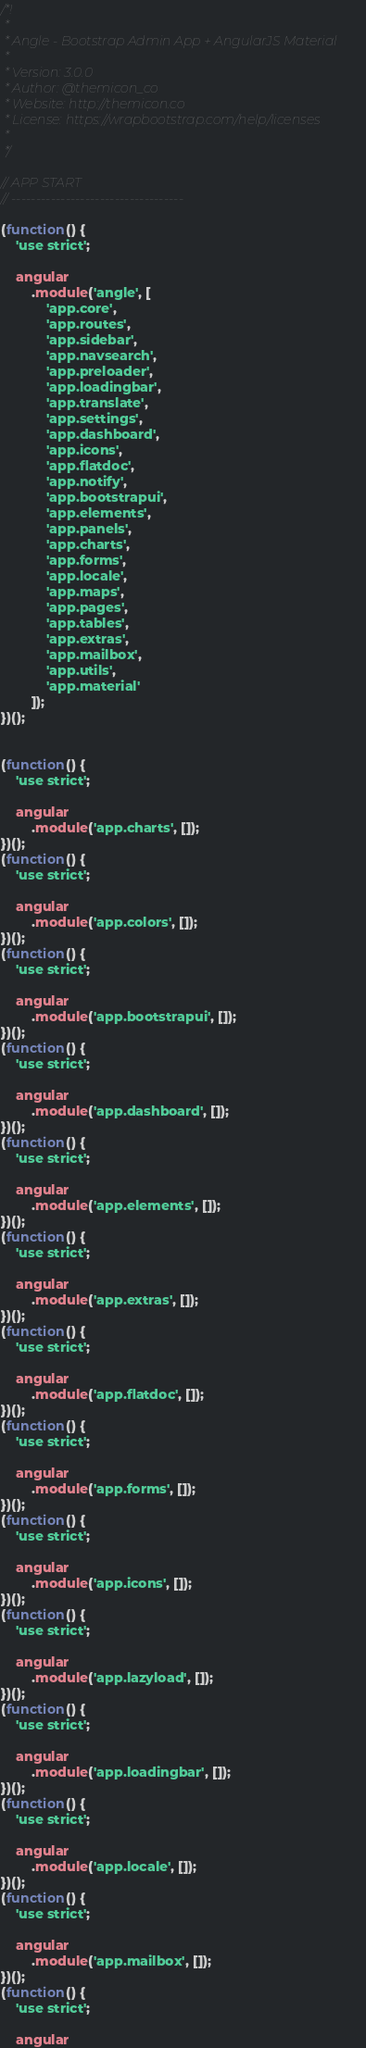Convert code to text. <code><loc_0><loc_0><loc_500><loc_500><_JavaScript_>/*!
 * 
 * Angle - Bootstrap Admin App + AngularJS Material
 * 
 * Version: 3.0.0
 * Author: @themicon_co
 * Website: http://themicon.co
 * License: https://wrapbootstrap.com/help/licenses
 * 
 */

// APP START
// ----------------------------------- 

(function() {
    'use strict';

    angular
        .module('angle', [
            'app.core',
            'app.routes',
            'app.sidebar',
            'app.navsearch',
            'app.preloader',
            'app.loadingbar',
            'app.translate',
            'app.settings',
            'app.dashboard',
            'app.icons',
            'app.flatdoc',
            'app.notify',
            'app.bootstrapui',
            'app.elements',
            'app.panels',
            'app.charts',
            'app.forms',
            'app.locale',
            'app.maps',
            'app.pages',
            'app.tables',
            'app.extras',
            'app.mailbox',
            'app.utils',
            'app.material'
        ]);
})();


(function() {
    'use strict';

    angular
        .module('app.charts', []);
})();
(function() {
    'use strict';

    angular
        .module('app.colors', []);
})();
(function() {
    'use strict';

    angular
        .module('app.bootstrapui', []);
})();
(function() {
    'use strict';

    angular
        .module('app.dashboard', []);
})();
(function() {
    'use strict';

    angular
        .module('app.elements', []);
})();
(function() {
    'use strict';

    angular
        .module('app.extras', []);
})();
(function() {
    'use strict';

    angular
        .module('app.flatdoc', []);
})();
(function() {
    'use strict';

    angular
        .module('app.forms', []);
})();
(function() {
    'use strict';

    angular
        .module('app.icons', []);
})();
(function() {
    'use strict';

    angular
        .module('app.lazyload', []);
})();
(function() {
    'use strict';

    angular
        .module('app.loadingbar', []);
})();
(function() {
    'use strict';

    angular
        .module('app.locale', []);
})();
(function() {
    'use strict';

    angular
        .module('app.mailbox', []);
})();
(function() {
    'use strict';

    angular</code> 